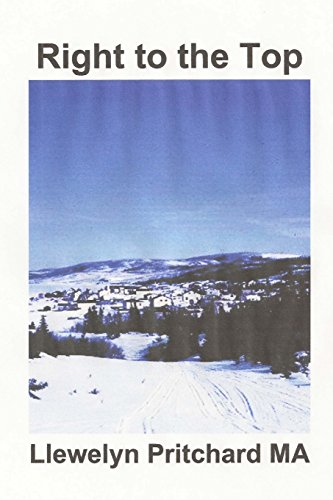What is the title of this book? The title of the book is 'Right to the Top: "Wrigglesworth corrupt group proceed with caution" (Port Hope Simpson Mysteries) (Volume 7) (Vietnamese Edition).' 